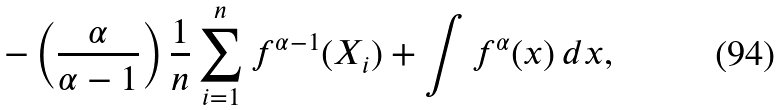Convert formula to latex. <formula><loc_0><loc_0><loc_500><loc_500>- \left ( \frac { \alpha } { \alpha - 1 } \right ) \frac { 1 } { n } \sum _ { i = 1 } ^ { n } f ^ { \alpha - 1 } ( X _ { i } ) + \int f ^ { \alpha } ( x ) \, d x ,</formula> 